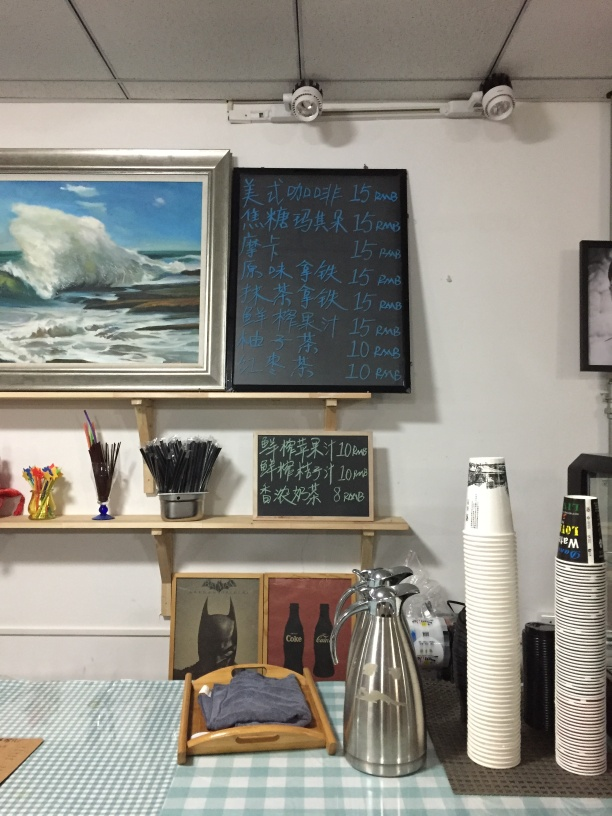What does the artwork on display and the layout tell us about this location? The artwork and layout suggest a creative environment, perhaps a combination of an art gallery and a café. The presence of paintings and art materials hints at a space promoting art appreciation and possibly the creation of art. Could this place be involved in art education or workshops? Given the setup with multiple canvases and a variety of painting tools, it's plausible that art education or workshops could be conducted here. The space seems designed to cater to art enthusiasts and practitioners alike. 